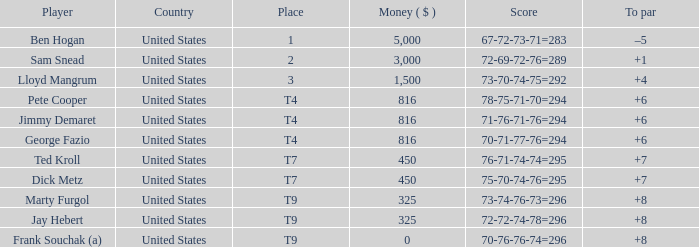How much was paid to the player whose score was 70-71-77-76=294? 816.0. 